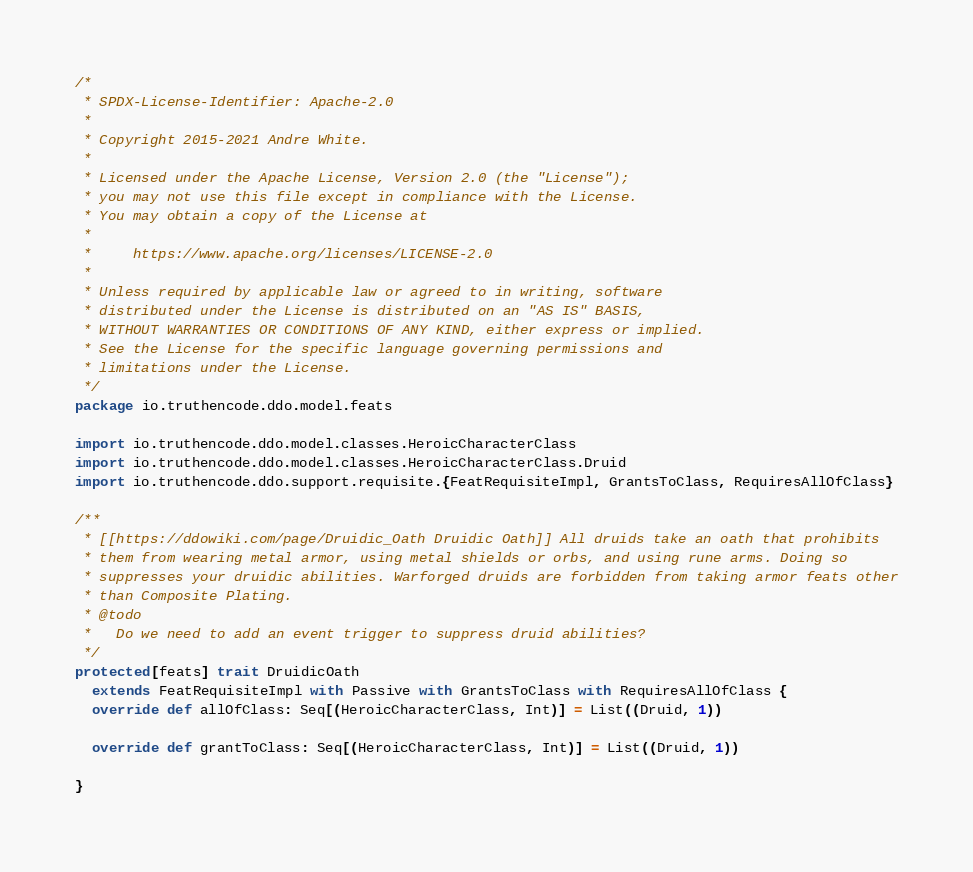<code> <loc_0><loc_0><loc_500><loc_500><_Scala_>/*
 * SPDX-License-Identifier: Apache-2.0
 *
 * Copyright 2015-2021 Andre White.
 *
 * Licensed under the Apache License, Version 2.0 (the "License");
 * you may not use this file except in compliance with the License.
 * You may obtain a copy of the License at
 *
 *     https://www.apache.org/licenses/LICENSE-2.0
 *
 * Unless required by applicable law or agreed to in writing, software
 * distributed under the License is distributed on an "AS IS" BASIS,
 * WITHOUT WARRANTIES OR CONDITIONS OF ANY KIND, either express or implied.
 * See the License for the specific language governing permissions and
 * limitations under the License.
 */
package io.truthencode.ddo.model.feats

import io.truthencode.ddo.model.classes.HeroicCharacterClass
import io.truthencode.ddo.model.classes.HeroicCharacterClass.Druid
import io.truthencode.ddo.support.requisite.{FeatRequisiteImpl, GrantsToClass, RequiresAllOfClass}

/**
 * [[https://ddowiki.com/page/Druidic_Oath Druidic Oath]] All druids take an oath that prohibits
 * them from wearing metal armor, using metal shields or orbs, and using rune arms. Doing so
 * suppresses your druidic abilities. Warforged druids are forbidden from taking armor feats other
 * than Composite Plating.
 * @todo
 *   Do we need to add an event trigger to suppress druid abilities?
 */
protected[feats] trait DruidicOath
  extends FeatRequisiteImpl with Passive with GrantsToClass with RequiresAllOfClass {
  override def allOfClass: Seq[(HeroicCharacterClass, Int)] = List((Druid, 1))

  override def grantToClass: Seq[(HeroicCharacterClass, Int)] = List((Druid, 1))

}
</code> 